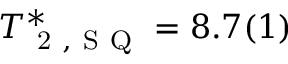Convert formula to latex. <formula><loc_0><loc_0><loc_500><loc_500>T _ { 2 , S Q } ^ { * } = 8 . 7 ( 1 )</formula> 